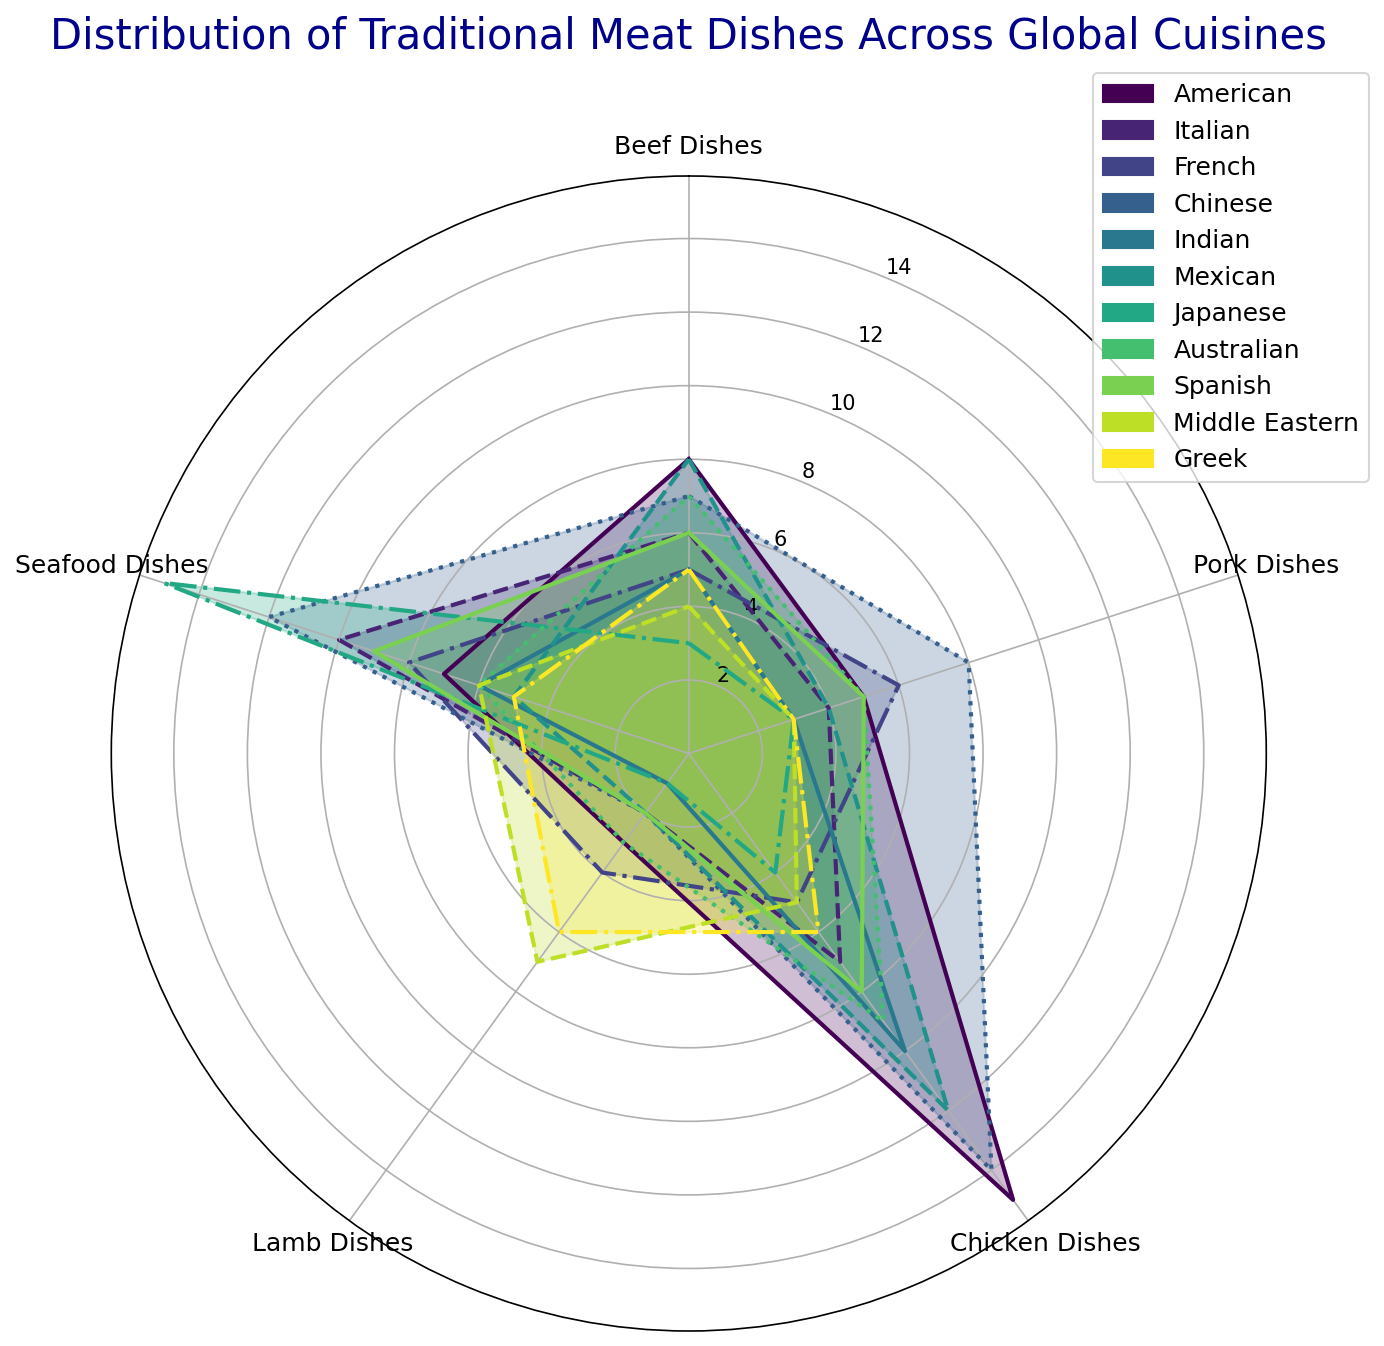What's the cuisine with the highest number of seafood dishes? By looking at the radar chart, we compare the seafood dishes data points across all cuisines. Japanese cuisine has the longest radius line for seafood dishes, indicating the highest number.
Answer: Japanese Which cuisine has more pork dishes: French or Spanish? From the radar chart, visually compare the length of the lines representing pork dishes for French and Spanish cuisines. French cuisine slightly surpasses Spanish cuisine in the length of the line for pork dishes.
Answer: French What is the total number of lamb dishes across American, Italian, and Greek cuisines? By locating and summing the data points for lamb dishes in the radar chart for American, Italian, and Greek cuisines, we get 3 (American) + 2 (Italian) + 6 (Greek) = 11.
Answer: 11 Which cuisine has fewer chicken dishes, Japanese or Middle Eastern? In the radar chart, compare the values of chicken dishes for Japanese and Middle Eastern cuisines. The line for chicken dishes is shorter for Japanese cuisine than for Middle Eastern.
Answer: Japanese If you average the number of beef dishes from Mexican, Indian, and Middle Eastern cuisines, what is the result? Sum the beef dishes from Mexican (8), Indian (5), and Middle Eastern (4) cuisines to get 8+5+4 = 17. Divide 17 by 3 to get the average, which is approximately 5.67.
Answer: 5.67 Which cuisine has the smallest variety of meat dishes overall (i.e., the lowest sum of all dish types listed)? By summing up the values for each cuisine across all meat dish types, Japanese cuisine yields a smaller total, demonstrating the shortest distances overall on the radar chart.
Answer: Japanese What is the difference in the number of beef dishes between American and Greek cuisines? Locate and subtract the value of beef dishes from Greek cuisine (5) from American cuisine (8) which is 8 - 5 = 3.
Answer: 3 Among the Indian and Italian cuisines, which one has a higher median value of meat dishes? For Indian cuisine, the values are [5, 3, 10, 1, 6]. Arranged in order, it becomes [1, 3, 5, 6, 10], and the median is 5. For Italian cuisine, the values are [6, 4, 7, 2, 10]. Arranged in order, it becomes [2, 4, 6, 7, 10], and the median is 6. Therefore, Italian cuisine has a higher median.
Answer: Italian Which cuisine shows a more balanced distribution of different meat dishes, American or Chinese? By looking at the radar chart, check how even the lengths of various dish type lines are for both cuisines. American cuisine shows a broader range of variance, while Chinese cuisine's radial lengths appear more evenly spread across different dish types.
Answer: Chinese 